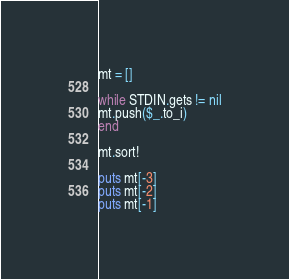Convert code to text. <code><loc_0><loc_0><loc_500><loc_500><_Ruby_>
mt = []

while STDIN.gets != nil
mt.push($_.to_i)
end

mt.sort!

puts mt[-3]
puts mt[-2]
puts mt[-1]</code> 